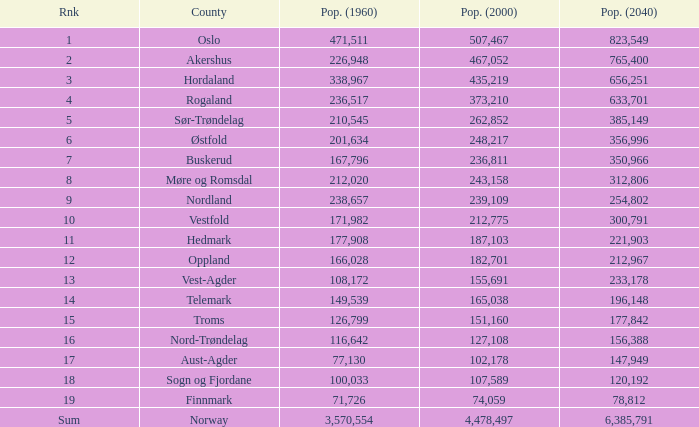What was Oslo's population in 1960, with a population of 507,467 in 2000? None. 